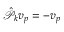Convert formula to latex. <formula><loc_0><loc_0><loc_500><loc_500>\hat { \mathcal { P } } _ { k } v _ { p } = - v _ { p }</formula> 